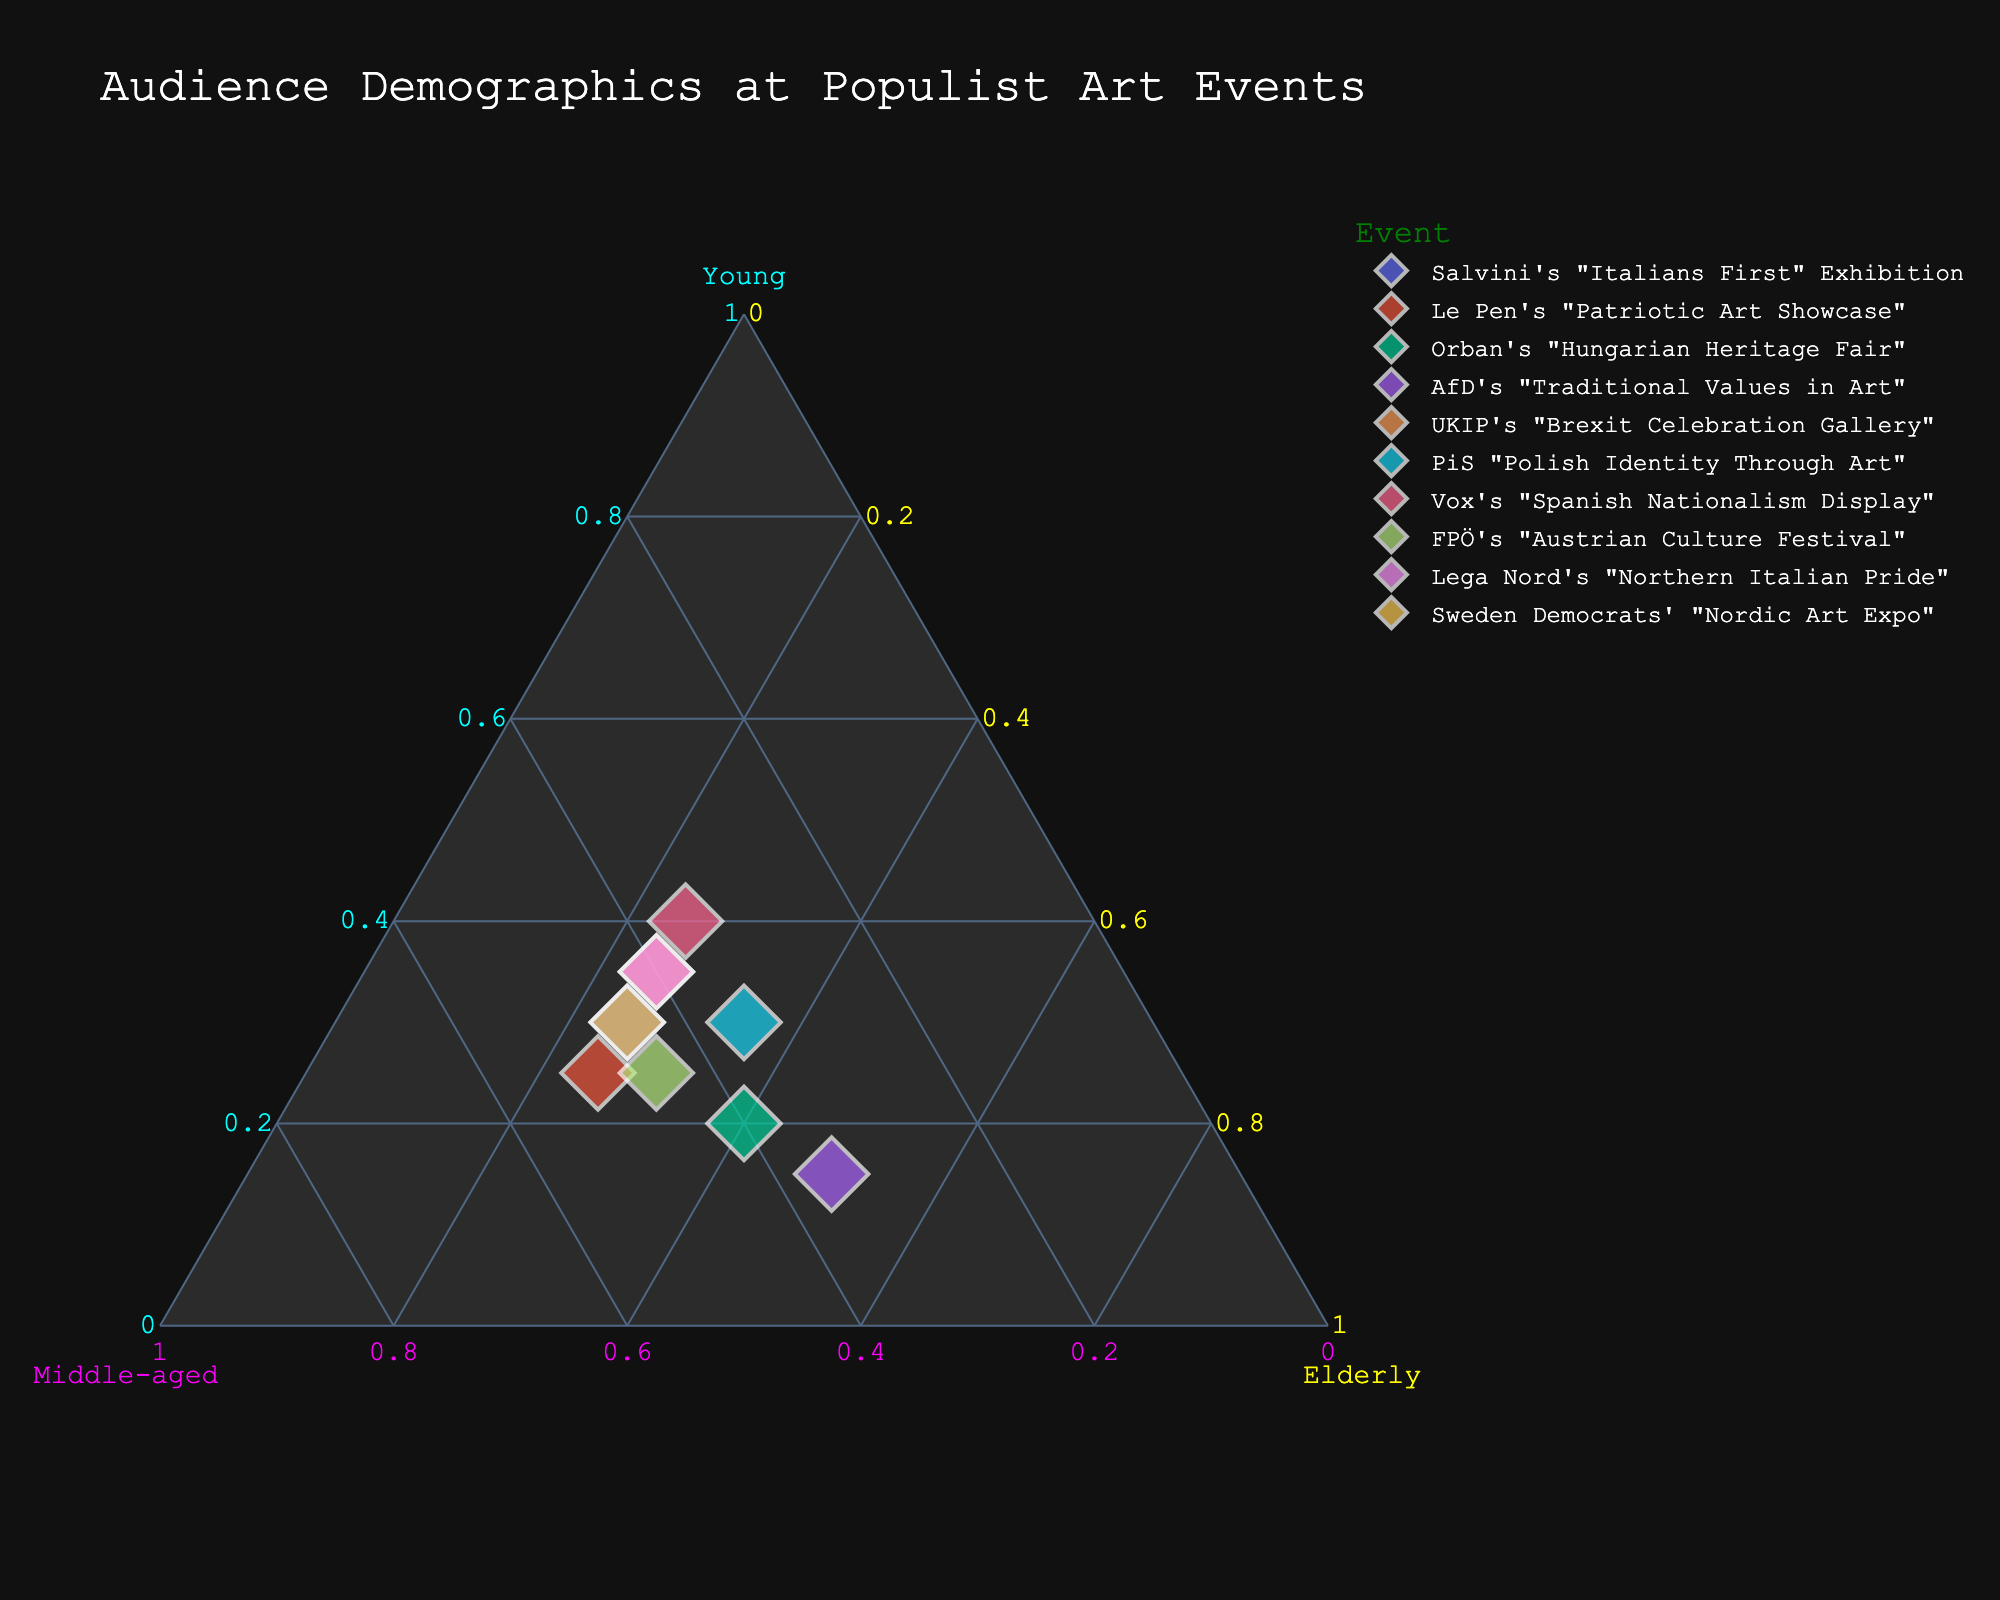What's the title of the plot? The title is displayed at the top center of the plot and provides a summary of what the plot represents. In this case, it is about audience demographics at populist art events.
Answer: Audience Demographics at Populist Art Events Which event has the highest percentage of young audience? Look for the point which is closest to the vertex labeled 'Young.' Higher value corresponds to a higher percentage.
Answer: Vox's "Spanish Nationalism Display" What is the color used for the "UKIP's Brexit Celebration Gallery"? By identifying the point corresponding to "UKIP's Brexit Celebration Gallery" and noting its color, you can determine the answer.
Answer: Not provided with specific color, but recognizable on the plot Which event has the largest proportion of elderly attendees? Look for the point closest to the 'Elderly' vertex on the ternary plot. This represents the highest percentage of elderly audience.
Answer: AfD's "Traditional Values in Art" Compare the audience composition of Salvini's "Italians First" Exhibition and Orban's "Hungarian Heritage Fair." Which has more young attendees? Find both points on the plot and see which one is closer to the 'Young' vertex. This tells you which event has more young attendees.
Answer: Salvini's "Italians First" Exhibition How do "Salvini's Italians First Exhibition" and "Vox's Spanish Nationalism Display" compare in terms of middle-aged attendees? Compare the distances of these two events from the vertex labeled 'Middle-aged.' The closer event has a higher percentage of middle-aged attendees.
Answer: Same percentage (35%) Which event is most balanced in terms of audience age distribution? Look for a point that is roughly equidistant from each vertex (Young, Middle-aged, Elderly) suggesting a balanced distribution.
Answer: PiS "Polish Identity Through Art" What percentage of the audience is young at FPÖ's "Austrian Culture Festival"? Locate the point for FPÖ's "Austrian Culture Festival" and look at its position relative to the 'Young' axis to derive the percentage.
Answer: 25% How many events have a higher percentage of middle-aged attendees compared to Elderly? Compare the positions of each event related to the 'Middle-aged' and 'Elderly' vertices to count how many fulfill this criterion.
Answer: 7 (Salvini's "Italians First" Exhibition, Le Pen's "Patriotic Art Showcase", UKIP's "Brexit Celebration Gallery", PiS "Polish Identity Through Art", Vox's "Spanish Nationalism Display", FPÖ's "Austrian Culture Festival", Sweden Democrats' "Nordic Art Expo" ) Between "Le Pen's Patriotic Art Showcase" and "Lega Nord's Northern Italian Pride," which event has more elderly attendees? Look at the distance from the 'Elderly' vertex for both events and compare. The closer one will indicate a higher percentage of elderly attendees.
Answer: Both have the same percentage (25%) 